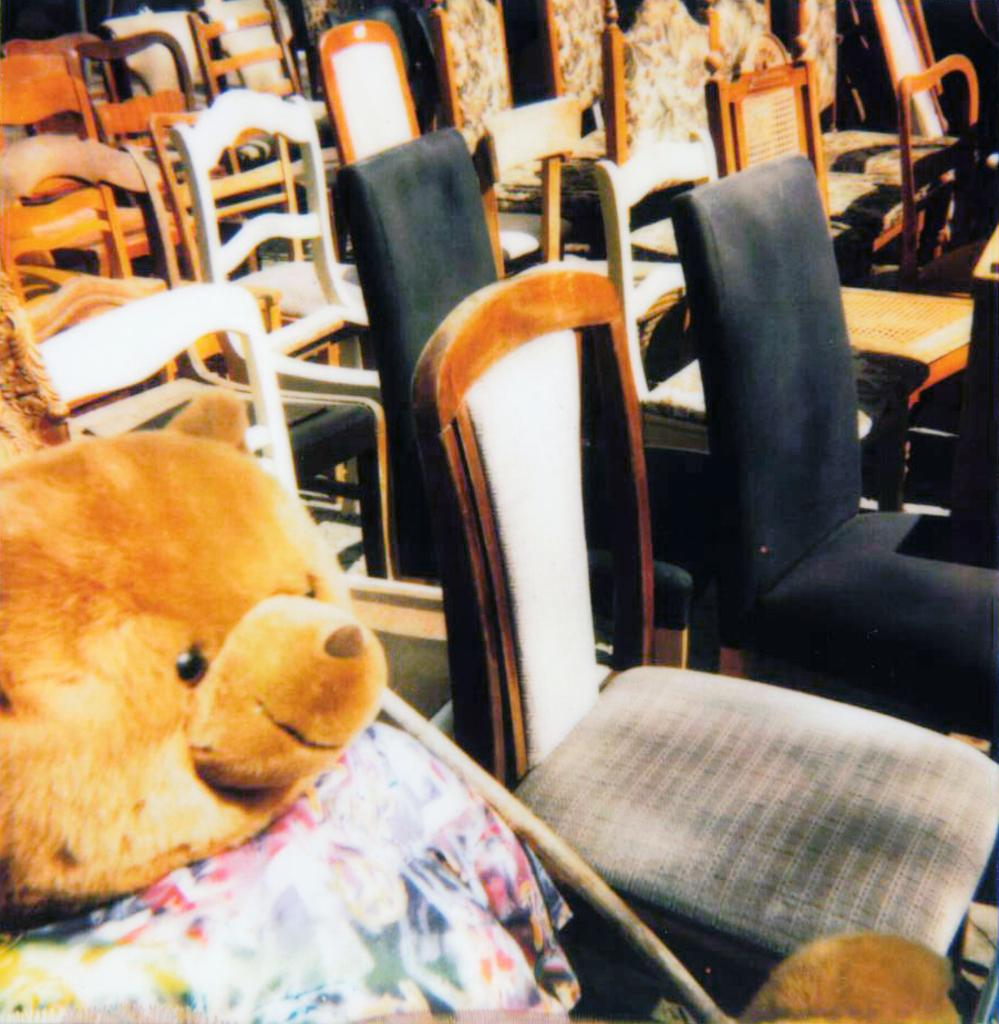What type of object is placed on a chair in the image? There is a soft toy in the image, and it is placed on a chair. How many chairs are visible in the room? There are multiple chairs in the room. What colors are the chairs in the room? The chairs are white, brown, and black in color. What kind of soft toy is placed on the chair? The soft toy is a teddy bear. What color is the teddy bear? The teddy bear is brown in color. How many pigs are sitting on the board in the image? There are no pigs or boards present in the image. Can you describe the icicle hanging from the teddy bear's nose in the image? There is no icicle present in the image; the teddy bear is a soft toy placed on a chair. 